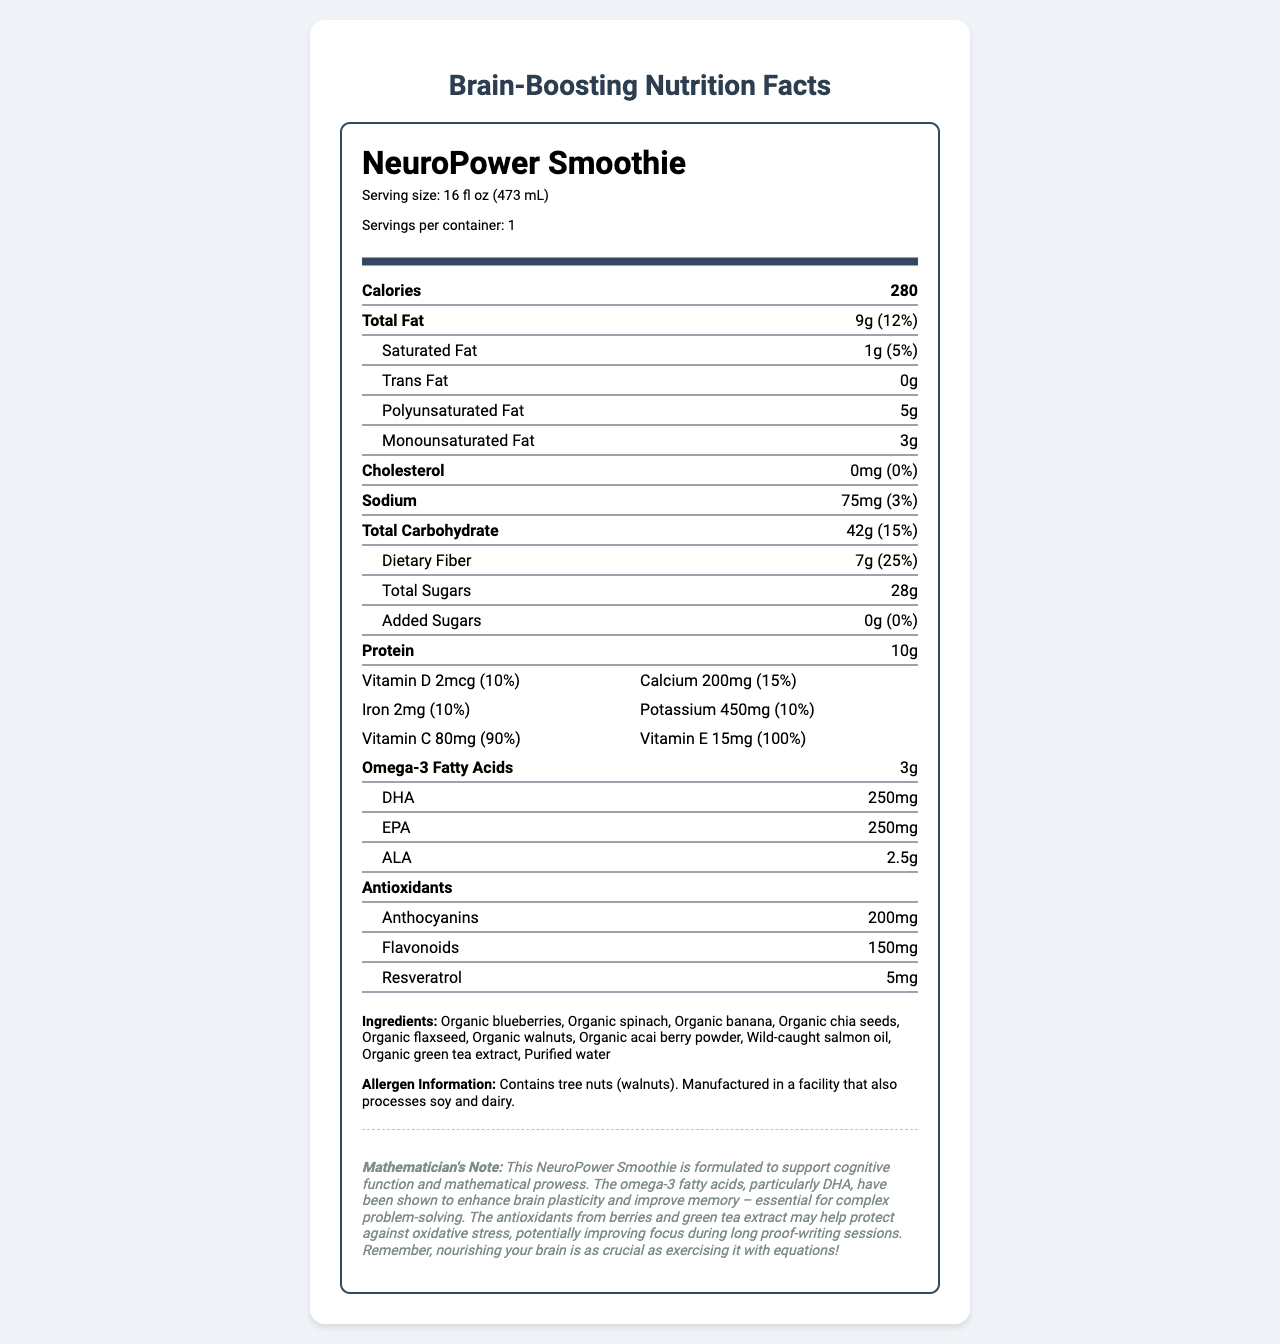how many calories are in one serving? The document lists the calorie content as 280 under the Calories section.
Answer: 280 what is the serving size of the NeuroPower Smoothie? The serving size is specified as "16 fl oz (473 mL)" in the document.
Answer: 16 fl oz (473 mL) how much dietary fiber does the smoothie contain? Under the Total Carbohydrate section, the document states that the dietary fiber amount is "7g".
Answer: 7g which type of fat is most abundant in the smoothie? The values for fats are provided, and among them, Polyunsaturated Fat has the highest value at "5g".
Answer: Polyunsaturated Fat are there any added sugars in the smoothie? The Added Sugars section shows "0g (0%)", indicating no added sugars.
Answer: No what allergens are present in the smoothie? The Allergen Information section mentions the presence of tree nuts (walnuts).
Answer: Tree nuts (walnuts) what are the primary ingredients in the smoothie? The ingredients are listed in the Ingredients section of the document.
Answer: Organic blueberries, Organic spinach, Organic banana, Organic chia seeds, Organic flaxseed, Organic walnuts, Organic acai berry powder, Wild-caught salmon oil, Organic green tea extract, Purified water how much omega-3 fatty acids does the smoothie contain? The Omega-3 Fatty Acids section shows the total amount as "3g".
Answer: 3g how much vitamin C is in the smoothie? A. 20mg B. 40mg C. 80mg D. 100mg The Vitamin C content is listed as "80mg (90%)", making option C correct.
Answer: C which vitamin has the highest daily value percentage in the smoothie? A. Vitamin D B. Calcium C. Vitamin C D. Vitamin E Among the listed vitamins, Vitamin E has a daily value of "100%", which is the highest.
Answer: D is there any cholesterol in the smoothie? The Cholesterol section states "0mg (0%)", indicating there is no cholesterol.
Answer: No summarize the main nutritional benefits of the NeuroPower Smoothie. The document provides detailed nutritional information, highlighting high omega-3 fatty acids, antioxidants, vitamins, and minerals that support brain functions and overall health.
Answer: The NeuroPower Smoothie contains a balanced mix of macronutrients and essential minerals that support cognitive functions. It's rich in omega-3 fatty acids, antioxidants, and vitamins, which enhance brain plasticity, memory, and focus. Additionally, it has high dietary fiber content and no added sugars, making it a nutritious choice for brain health. what is the price of the NeuroPower Smoothie? The document does not contain any information regarding the price of the NeuroPower Smoothie.
Answer: Cannot be determined 